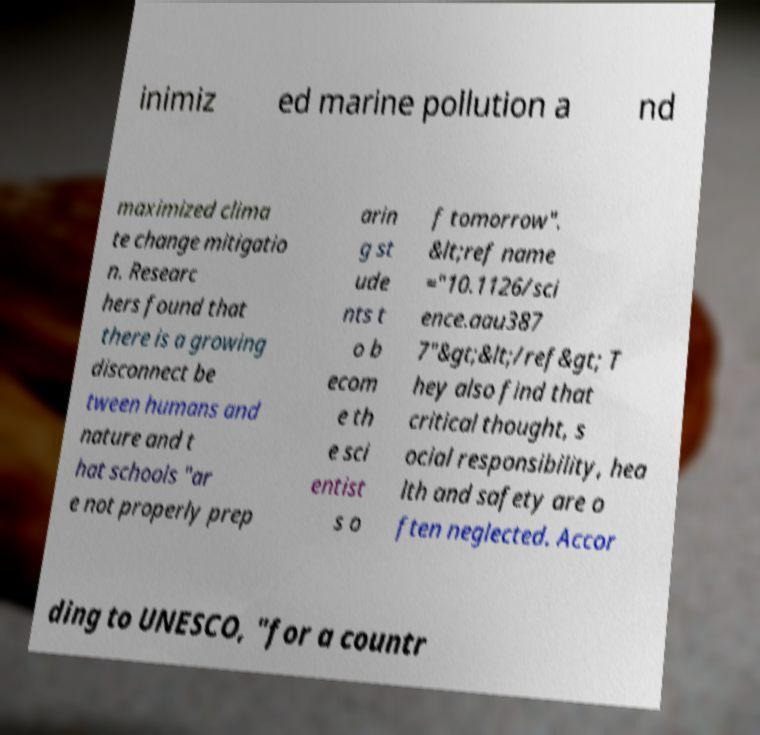Can you accurately transcribe the text from the provided image for me? inimiz ed marine pollution a nd maximized clima te change mitigatio n. Researc hers found that there is a growing disconnect be tween humans and nature and t hat schools "ar e not properly prep arin g st ude nts t o b ecom e th e sci entist s o f tomorrow". &lt;ref name ="10.1126/sci ence.aau387 7"&gt;&lt;/ref&gt; T hey also find that critical thought, s ocial responsibility, hea lth and safety are o ften neglected. Accor ding to UNESCO, "for a countr 